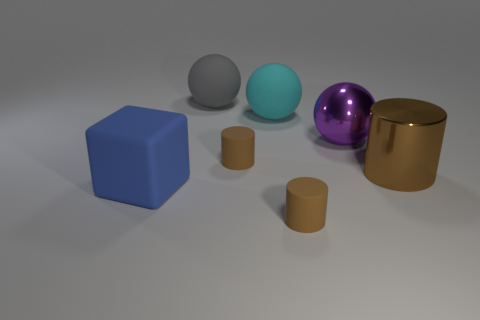The brown metal object is what shape?
Your response must be concise. Cylinder. Is there anything else that has the same shape as the blue rubber thing?
Ensure brevity in your answer.  No. Are there fewer big gray things in front of the big purple sphere than small green shiny cylinders?
Make the answer very short. No. Is the color of the small rubber thing on the right side of the big cyan matte thing the same as the large metal cylinder?
Provide a short and direct response. Yes. How many matte objects are small red spheres or big cyan balls?
Provide a short and direct response. 1. What is the color of the other big object that is made of the same material as the large purple thing?
Give a very brief answer. Brown. What number of cubes are either large cyan things or red shiny things?
Ensure brevity in your answer.  0. What number of things are either purple shiny things or brown things that are behind the blue matte block?
Your answer should be compact. 3. Is there a tiny shiny sphere?
Keep it short and to the point. No. How many large cylinders are the same color as the matte block?
Give a very brief answer. 0. 